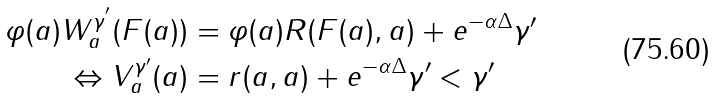Convert formula to latex. <formula><loc_0><loc_0><loc_500><loc_500>\varphi ( a ) W ^ { \gamma ^ { ^ { \prime } } } _ { a } ( F ( a ) ) & = \varphi ( a ) R ( F ( a ) , a ) + e ^ { - \alpha \Delta } \gamma ^ { \prime } \\ \Leftrightarrow V _ { a } ^ { \gamma ^ { \prime } } ( a ) & = r ( a , a ) + e ^ { - \alpha \Delta } \gamma ^ { \prime } < \gamma ^ { \prime }</formula> 